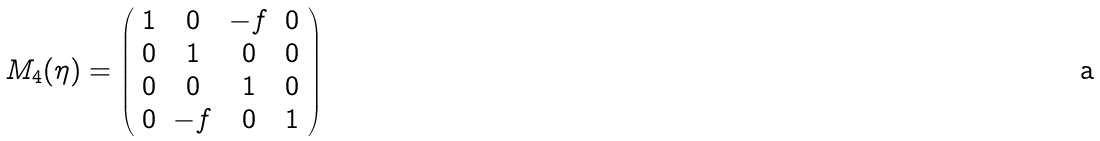Convert formula to latex. <formula><loc_0><loc_0><loc_500><loc_500>M _ { 4 } ( \eta ) = \left ( \begin{array} { c c c c } 1 & 0 & - f & 0 \\ 0 & 1 & 0 & 0 \\ 0 & 0 & 1 & 0 \\ 0 & - f & 0 & 1 \\ \end{array} \right )</formula> 